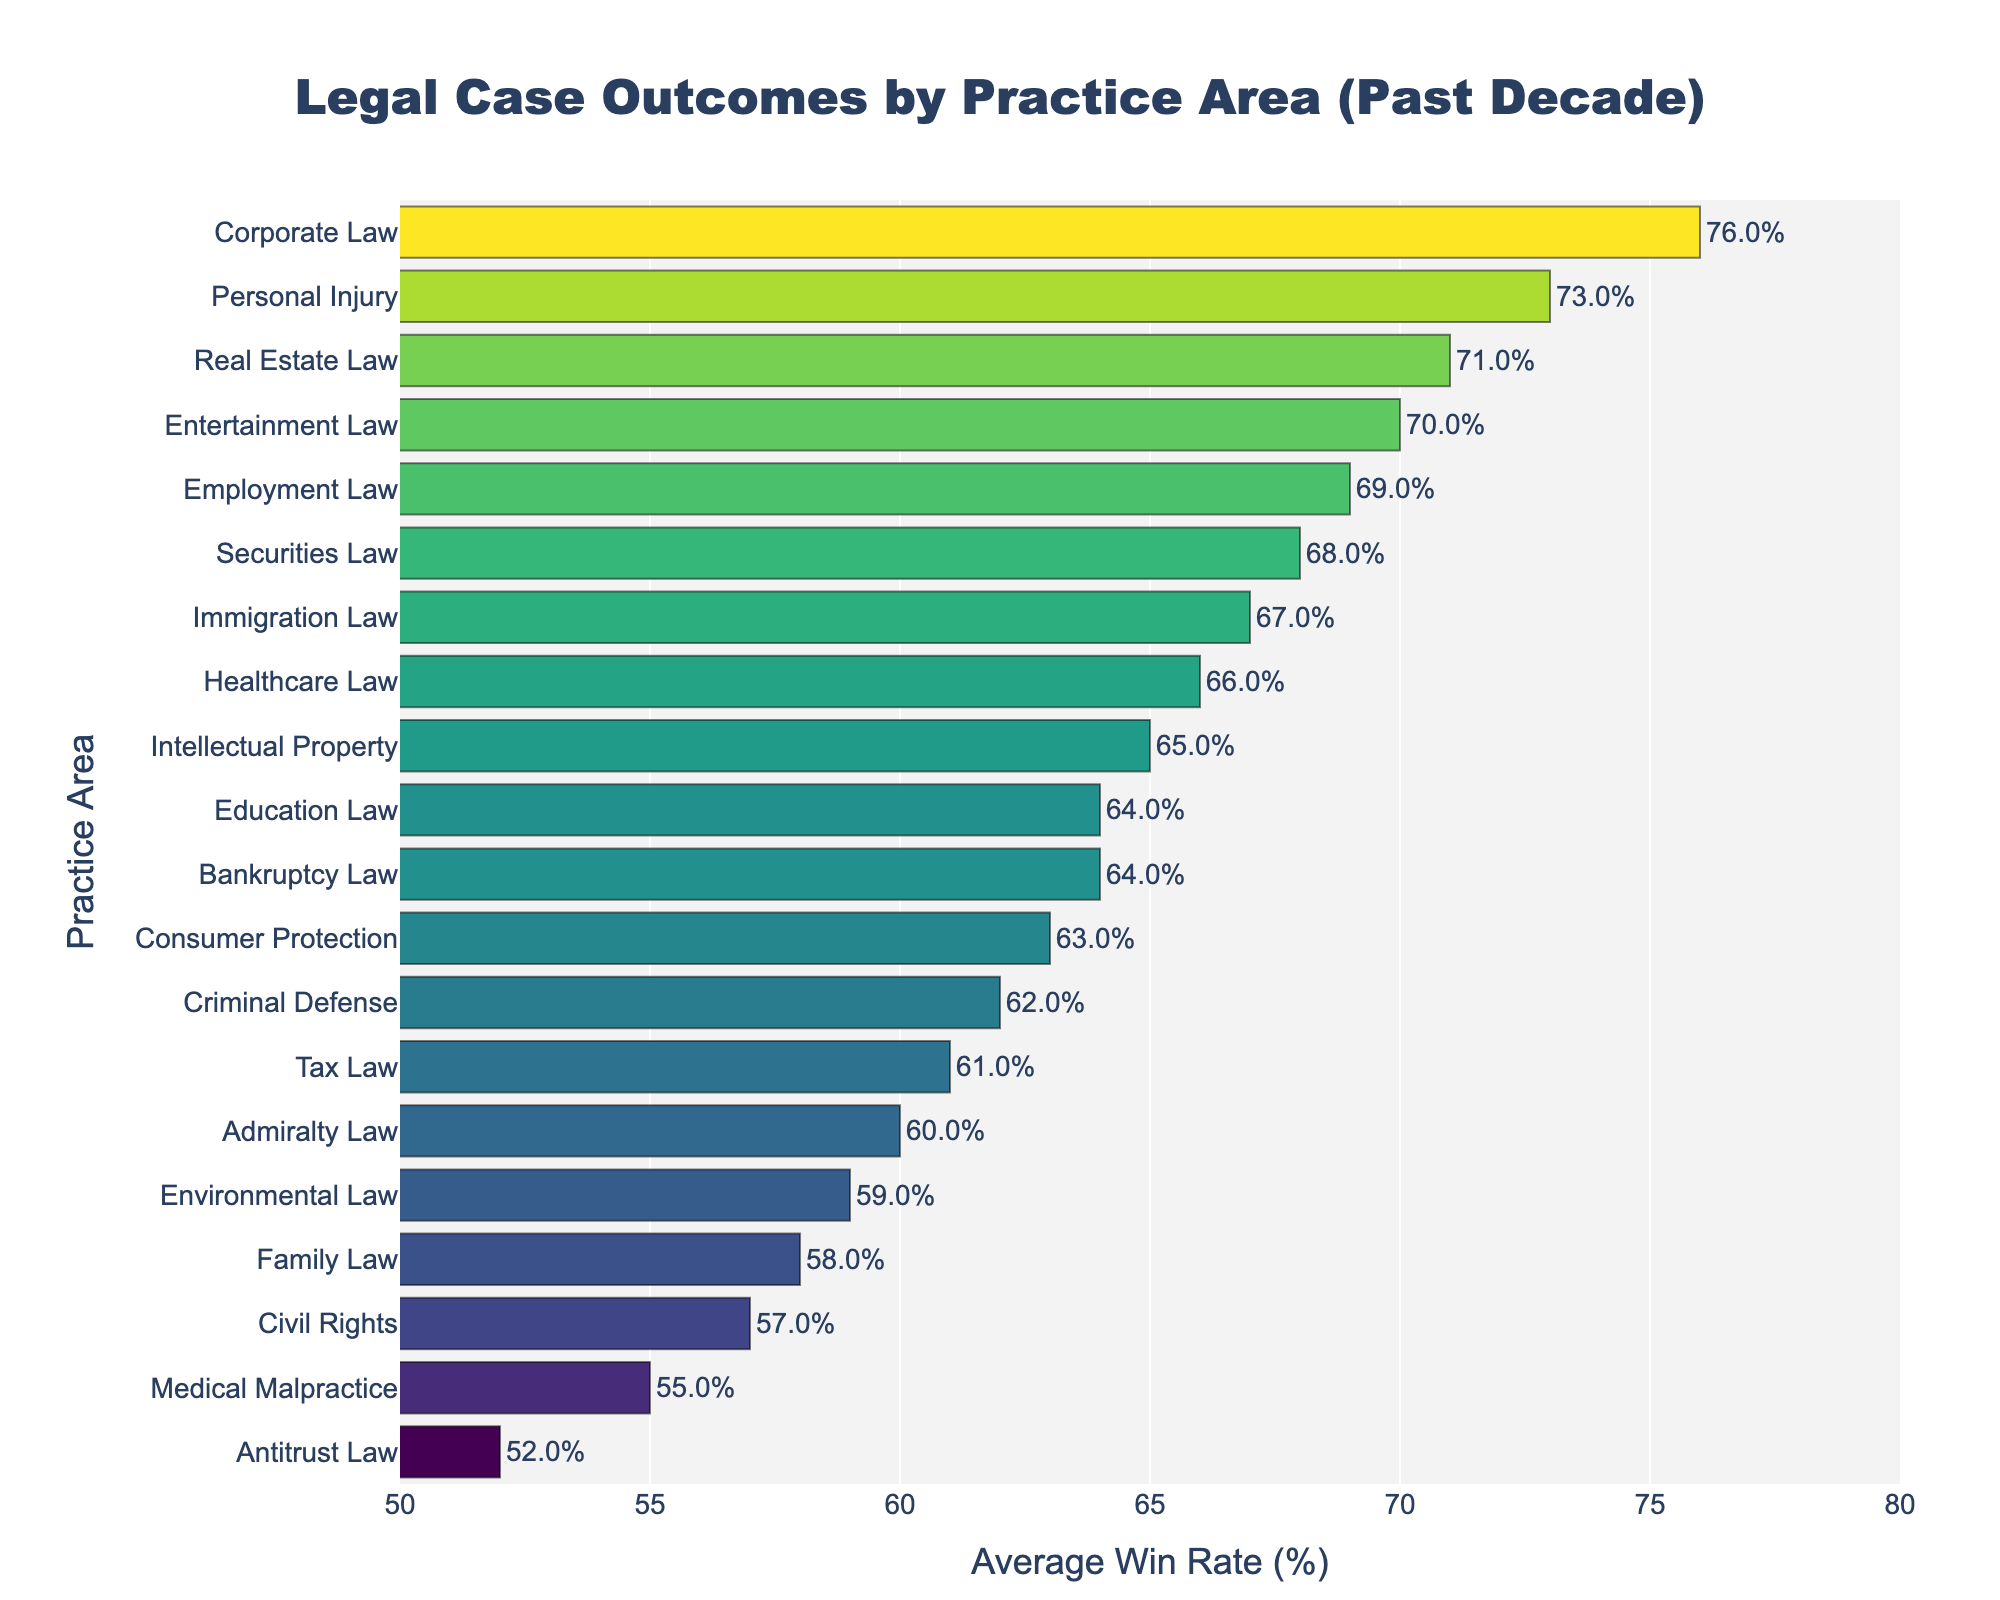Which practice area has the highest average win rate? The bar representing Corporate Law is the longest and reaches the highest value on the x-axis, indicating 76%.
Answer: Corporate Law What is the difference in average win rates between the highest and lowest practice areas? Corporate Law has the highest win rate at 76%, and Antitrust Law has the lowest at 52%. The difference is 76% - 52% = 24%.
Answer: 24% Which practice areas have win rates above 70%? The bars for Corporate Law, Personal Injury, Real Estate Law, and Entertainment Law all extend past the 70% mark on the x-axis.
Answer: Corporate Law, Personal Injury, Real Estate Law, Entertainment Law Which practice area has a win rate closest to 60%? Admiralty Law, with a win rate of 60%, is closest to 60%. Admiralty Law's bar is almost equal to the 60% mark on the x-axis.
Answer: Admiralty Law How does the win rate of Criminal Defense compare to Family Law? The bar for Criminal Defense is slightly longer than Family Law, indicating Criminal Defense has a slightly higher win rate of 62% compared to Family Law's 58%.
Answer: Criminal Defense has a higher win rate What is the average win rate of the three lowest-rated practice areas? The three lowest win rates are Antitrust Law (52%), Medical Malpractice (55%), and Civil Rights (57%). The average is calculated as (52 + 55 + 57) / 3 = 54.7%.
Answer: 54.7% Which practice areas have win rates that are exactly or almost halfway (65%) between the lowest and highest average win rates? Intellectual Property and Healthcare Law both have win rates at or near 65%, halfway between 52% and 76%.
Answer: Intellectual Property, Healthcare Law What is the collective difference in win rates between Employment Law and the practice areas directly above and below it? Employment Law has a win rate of 69%. The practice areas directly above are Intellectual Property (65%) and Real Estate Law (71%). The differences are 69% - 65% = 4% and 71% - 69% = 2%. Summing these differences: 4% + 2% = 6%.
Answer: 6% How many practice areas have win rates less than 60%? The practice areas falling under the 60% mark are Family Law, Environmental Law, Civil Rights, Medical Malpractice, and Antitrust Law, totaling 5 areas.
Answer: 5 practice areas 